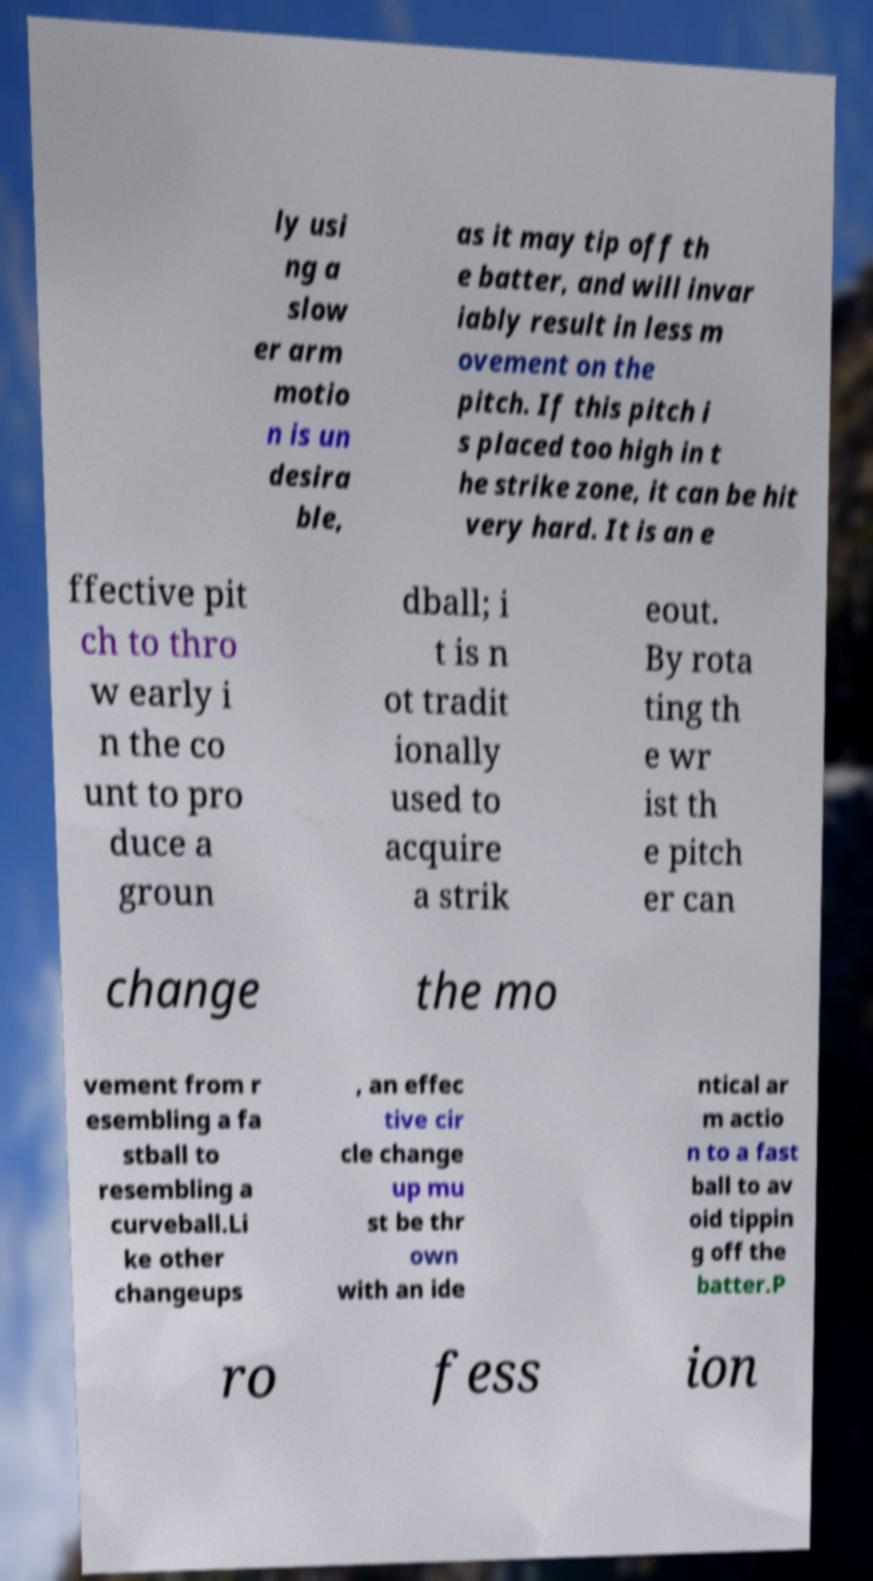Can you read and provide the text displayed in the image?This photo seems to have some interesting text. Can you extract and type it out for me? ly usi ng a slow er arm motio n is un desira ble, as it may tip off th e batter, and will invar iably result in less m ovement on the pitch. If this pitch i s placed too high in t he strike zone, it can be hit very hard. It is an e ffective pit ch to thro w early i n the co unt to pro duce a groun dball; i t is n ot tradit ionally used to acquire a strik eout. By rota ting th e wr ist th e pitch er can change the mo vement from r esembling a fa stball to resembling a curveball.Li ke other changeups , an effec tive cir cle change up mu st be thr own with an ide ntical ar m actio n to a fast ball to av oid tippin g off the batter.P ro fess ion 